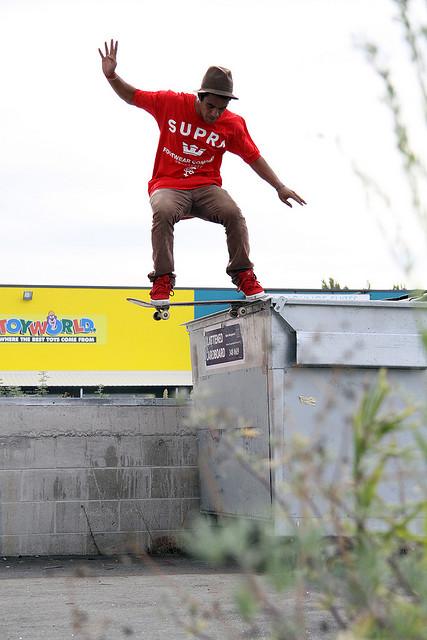What is the shirt written?
Quick response, please. Supra. What is the man doing?
Write a very short answer. Skateboarding. What color is his shirt?
Be succinct. Red. 